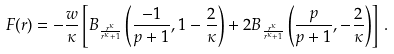<formula> <loc_0><loc_0><loc_500><loc_500>F ( r ) = - \frac { w } { \kappa } \left [ B _ { \frac { r ^ { \kappa } } { r ^ { \kappa } + 1 } } \left ( \frac { - 1 } { p + 1 } , 1 - \frac { 2 } { \kappa } \right ) + 2 B _ { \frac { r ^ { \kappa } } { r ^ { \kappa } + 1 } } \left ( \frac { p } { p + 1 } , - \frac { 2 } { \kappa } \right ) \right ] \, .</formula> 